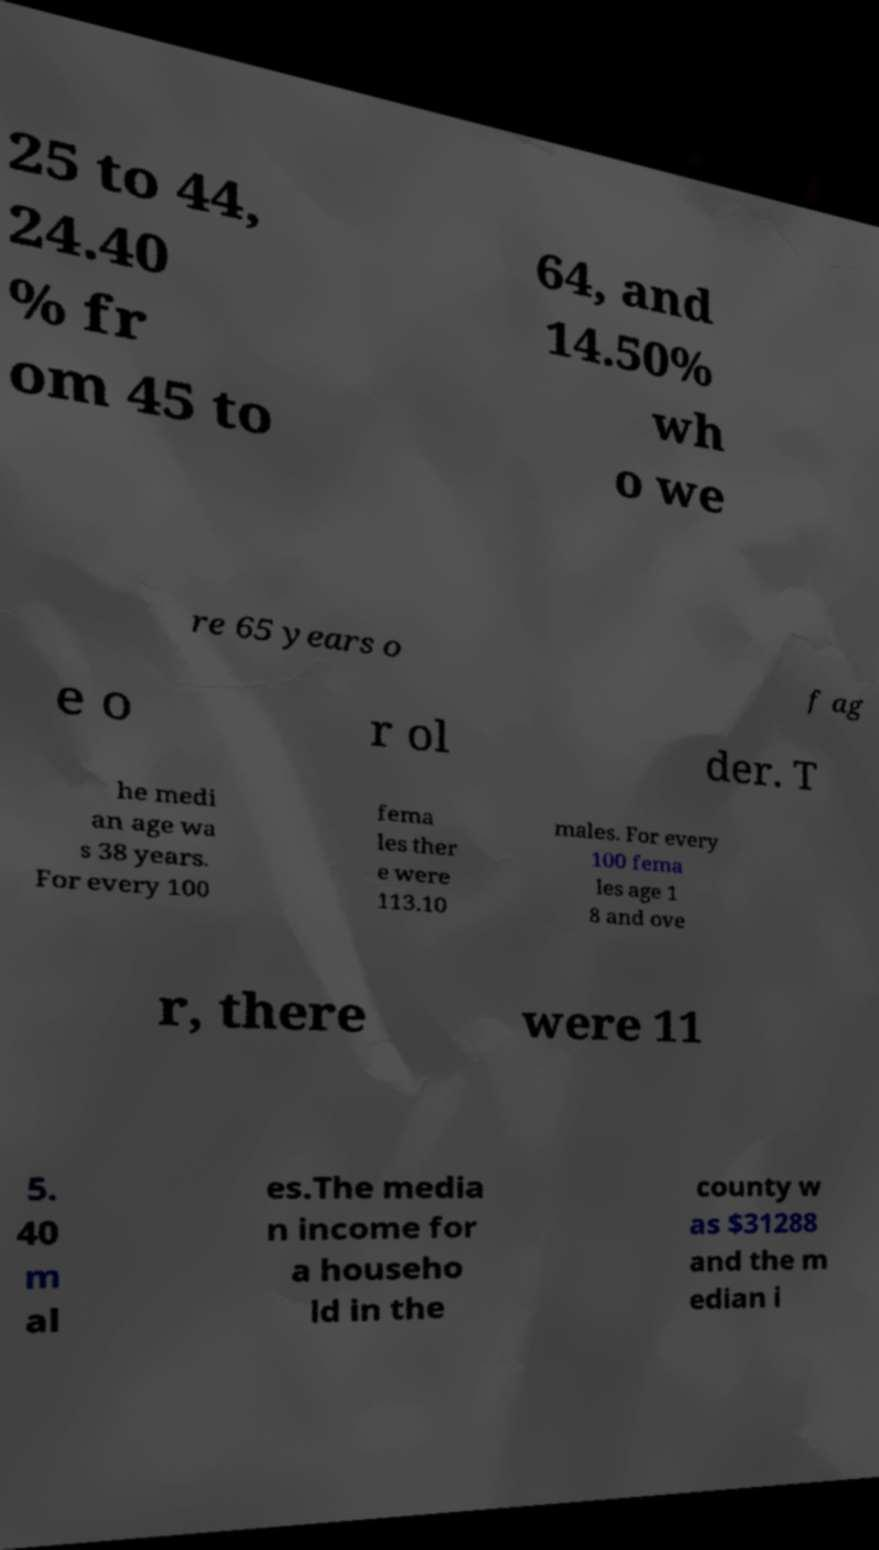There's text embedded in this image that I need extracted. Can you transcribe it verbatim? 25 to 44, 24.40 % fr om 45 to 64, and 14.50% wh o we re 65 years o f ag e o r ol der. T he medi an age wa s 38 years. For every 100 fema les ther e were 113.10 males. For every 100 fema les age 1 8 and ove r, there were 11 5. 40 m al es.The media n income for a househo ld in the county w as $31288 and the m edian i 